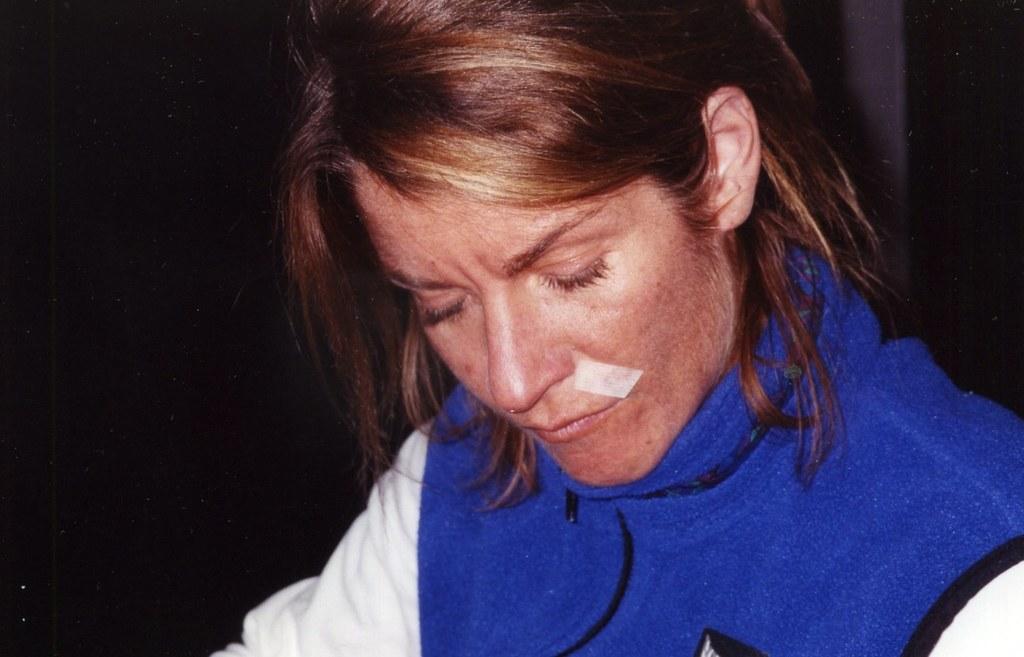How would you summarize this image in a sentence or two? In this image in the foreground there is one woman, and in the background there is a wall. 